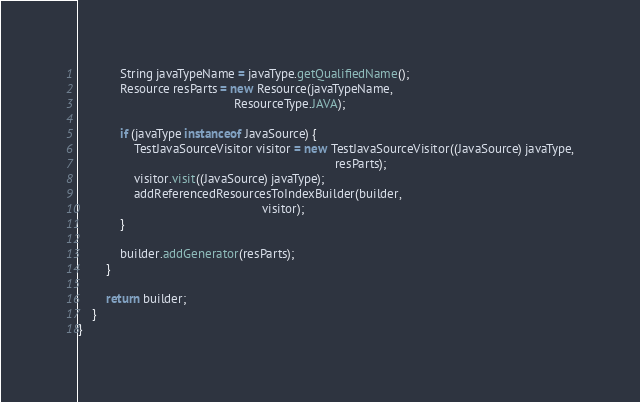Convert code to text. <code><loc_0><loc_0><loc_500><loc_500><_Java_>
            String javaTypeName = javaType.getQualifiedName();
            Resource resParts = new Resource(javaTypeName,
                                             ResourceType.JAVA);

            if (javaType instanceof JavaSource) {
                TestJavaSourceVisitor visitor = new TestJavaSourceVisitor((JavaSource) javaType,
                                                                          resParts);
                visitor.visit((JavaSource) javaType);
                addReferencedResourcesToIndexBuilder(builder,
                                                     visitor);
            }

            builder.addGenerator(resParts);
        }

        return builder;
    }
}
</code> 